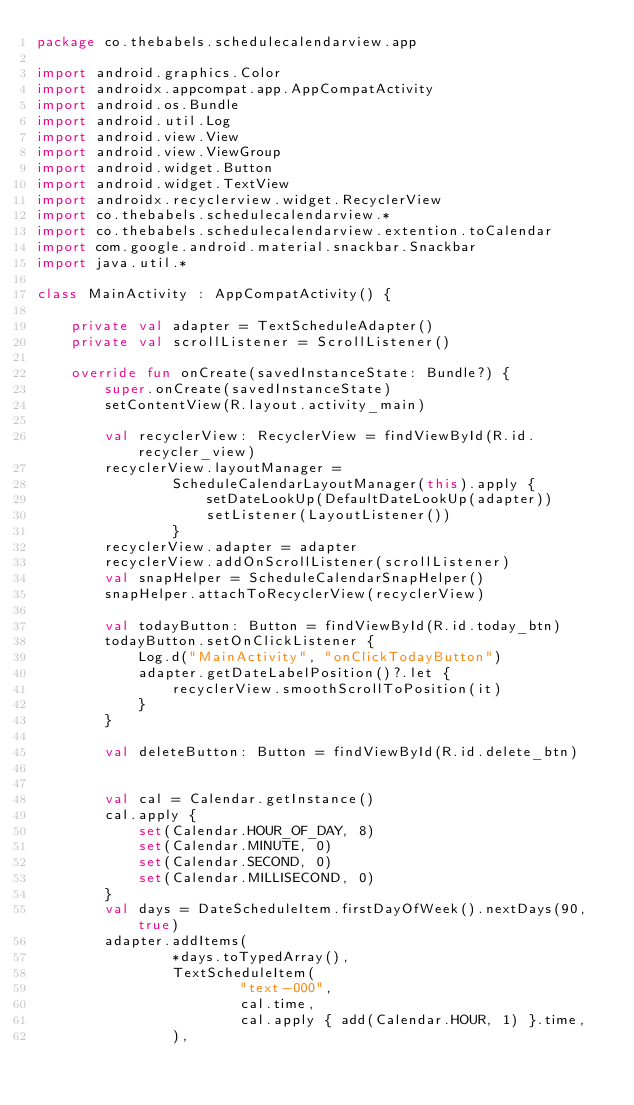Convert code to text. <code><loc_0><loc_0><loc_500><loc_500><_Kotlin_>package co.thebabels.schedulecalendarview.app

import android.graphics.Color
import androidx.appcompat.app.AppCompatActivity
import android.os.Bundle
import android.util.Log
import android.view.View
import android.view.ViewGroup
import android.widget.Button
import android.widget.TextView
import androidx.recyclerview.widget.RecyclerView
import co.thebabels.schedulecalendarview.*
import co.thebabels.schedulecalendarview.extention.toCalendar
import com.google.android.material.snackbar.Snackbar
import java.util.*

class MainActivity : AppCompatActivity() {

    private val adapter = TextScheduleAdapter()
    private val scrollListener = ScrollListener()

    override fun onCreate(savedInstanceState: Bundle?) {
        super.onCreate(savedInstanceState)
        setContentView(R.layout.activity_main)

        val recyclerView: RecyclerView = findViewById(R.id.recycler_view)
        recyclerView.layoutManager =
                ScheduleCalendarLayoutManager(this).apply {
                    setDateLookUp(DefaultDateLookUp(adapter))
                    setListener(LayoutListener())
                }
        recyclerView.adapter = adapter
        recyclerView.addOnScrollListener(scrollListener)
        val snapHelper = ScheduleCalendarSnapHelper()
        snapHelper.attachToRecyclerView(recyclerView)

        val todayButton: Button = findViewById(R.id.today_btn)
        todayButton.setOnClickListener {
            Log.d("MainActivity", "onClickTodayButton")
            adapter.getDateLabelPosition()?.let {
                recyclerView.smoothScrollToPosition(it)
            }
        }

        val deleteButton: Button = findViewById(R.id.delete_btn)


        val cal = Calendar.getInstance()
        cal.apply {
            set(Calendar.HOUR_OF_DAY, 8)
            set(Calendar.MINUTE, 0)
            set(Calendar.SECOND, 0)
            set(Calendar.MILLISECOND, 0)
        }
        val days = DateScheduleItem.firstDayOfWeek().nextDays(90, true)
        adapter.addItems(
                *days.toTypedArray(),
                TextScheduleItem(
                        "text-000",
                        cal.time,
                        cal.apply { add(Calendar.HOUR, 1) }.time,
                ),</code> 